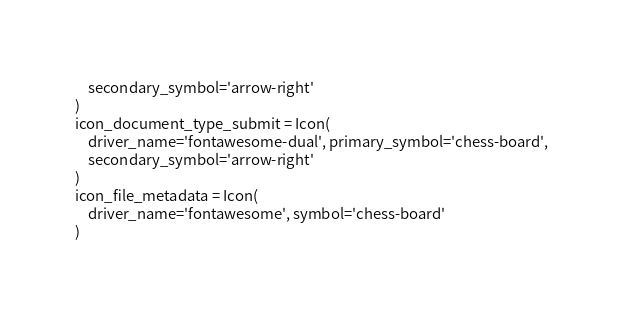Convert code to text. <code><loc_0><loc_0><loc_500><loc_500><_Python_>    secondary_symbol='arrow-right'
)
icon_document_type_submit = Icon(
    driver_name='fontawesome-dual', primary_symbol='chess-board',
    secondary_symbol='arrow-right'
)
icon_file_metadata = Icon(
    driver_name='fontawesome', symbol='chess-board'
)
</code> 